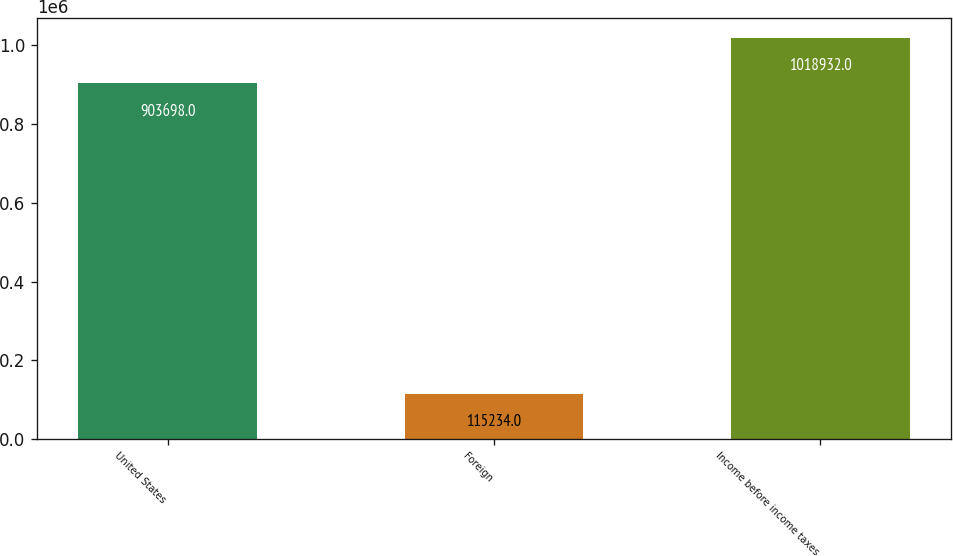Convert chart to OTSL. <chart><loc_0><loc_0><loc_500><loc_500><bar_chart><fcel>United States<fcel>Foreign<fcel>Income before income taxes<nl><fcel>903698<fcel>115234<fcel>1.01893e+06<nl></chart> 